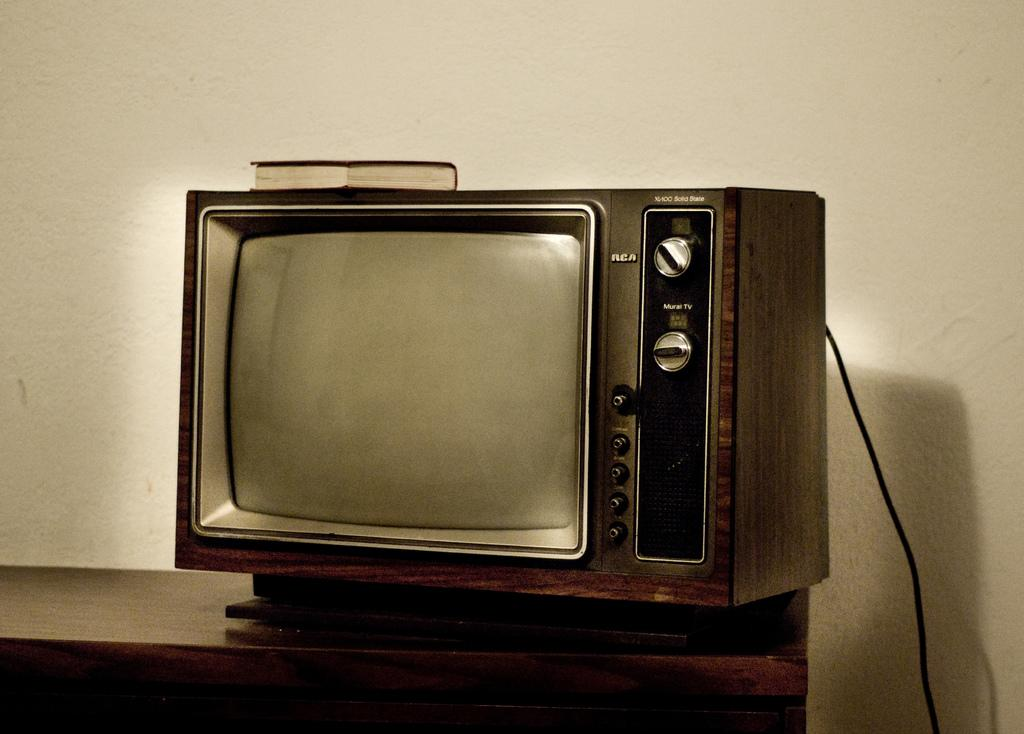<image>
Share a concise interpretation of the image provided. a very old RCA television sits atop a wood table 